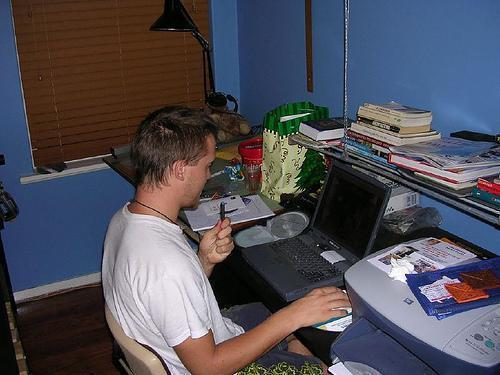What is he doing?
Indicate the correct response by choosing from the four available options to answer the question.
Options: Eating fruit, playing game, recording voice, testing mouse. Recording voice. 